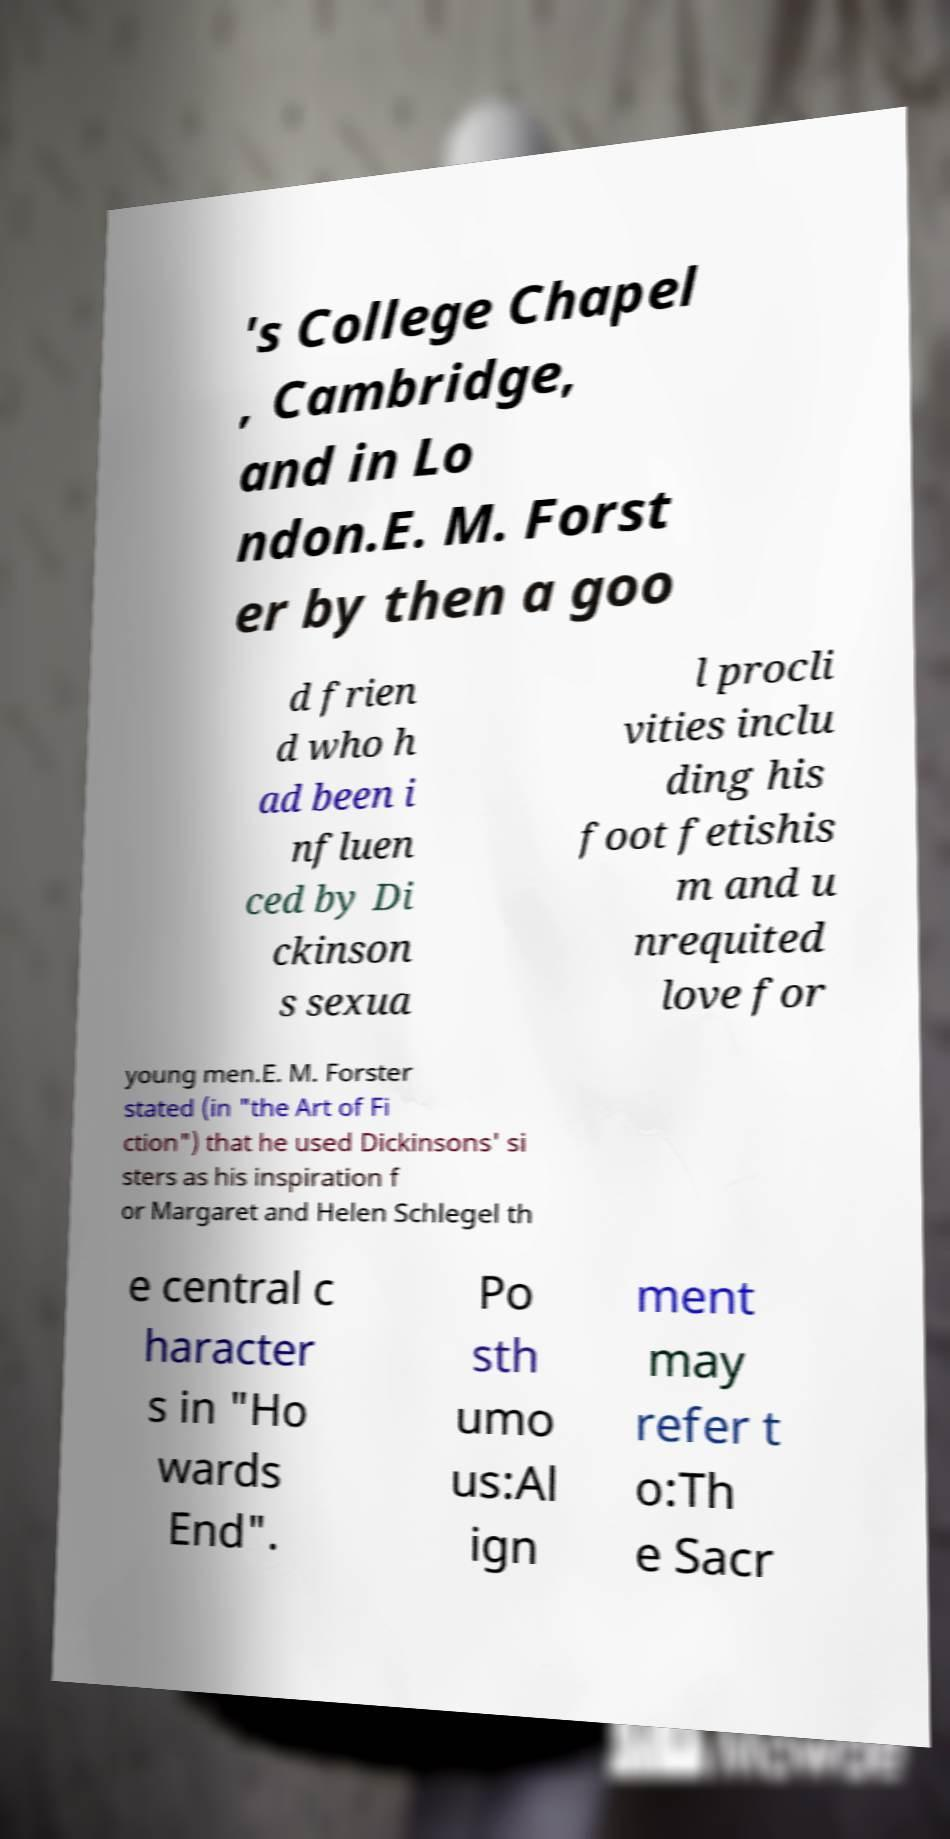There's text embedded in this image that I need extracted. Can you transcribe it verbatim? 's College Chapel , Cambridge, and in Lo ndon.E. M. Forst er by then a goo d frien d who h ad been i nfluen ced by Di ckinson s sexua l procli vities inclu ding his foot fetishis m and u nrequited love for young men.E. M. Forster stated (in "the Art of Fi ction") that he used Dickinsons' si sters as his inspiration f or Margaret and Helen Schlegel th e central c haracter s in "Ho wards End". Po sth umo us:Al ign ment may refer t o:Th e Sacr 